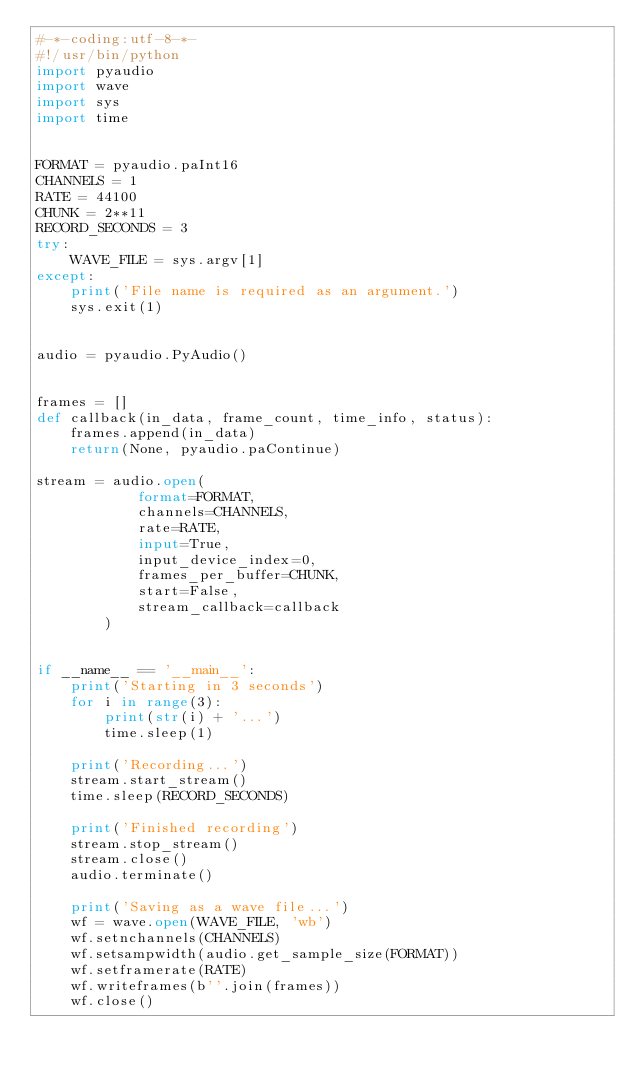<code> <loc_0><loc_0><loc_500><loc_500><_Python_>#-*-coding:utf-8-*-
#!/usr/bin/python
import pyaudio
import wave
import sys
import time


FORMAT = pyaudio.paInt16
CHANNELS = 1
RATE = 44100
CHUNK = 2**11
RECORD_SECONDS = 3
try:
    WAVE_FILE = sys.argv[1]
except:
    print('File name is required as an argument.')
    sys.exit(1)


audio = pyaudio.PyAudio()


frames = []
def callback(in_data, frame_count, time_info, status):
    frames.append(in_data)
    return(None, pyaudio.paContinue)

stream = audio.open(
            format=FORMAT,
            channels=CHANNELS,
            rate=RATE,
            input=True,
            input_device_index=0,
            frames_per_buffer=CHUNK,
            start=False,
            stream_callback=callback
        )


if __name__ == '__main__':
    print('Starting in 3 seconds')
    for i in range(3):
        print(str(i) + '...')
        time.sleep(1)

    print('Recording...')
    stream.start_stream()
    time.sleep(RECORD_SECONDS)

    print('Finished recording')
    stream.stop_stream()
    stream.close()
    audio.terminate()

    print('Saving as a wave file...')
    wf = wave.open(WAVE_FILE, 'wb')
    wf.setnchannels(CHANNELS)
    wf.setsampwidth(audio.get_sample_size(FORMAT))
    wf.setframerate(RATE)
    wf.writeframes(b''.join(frames))
    wf.close()
</code> 